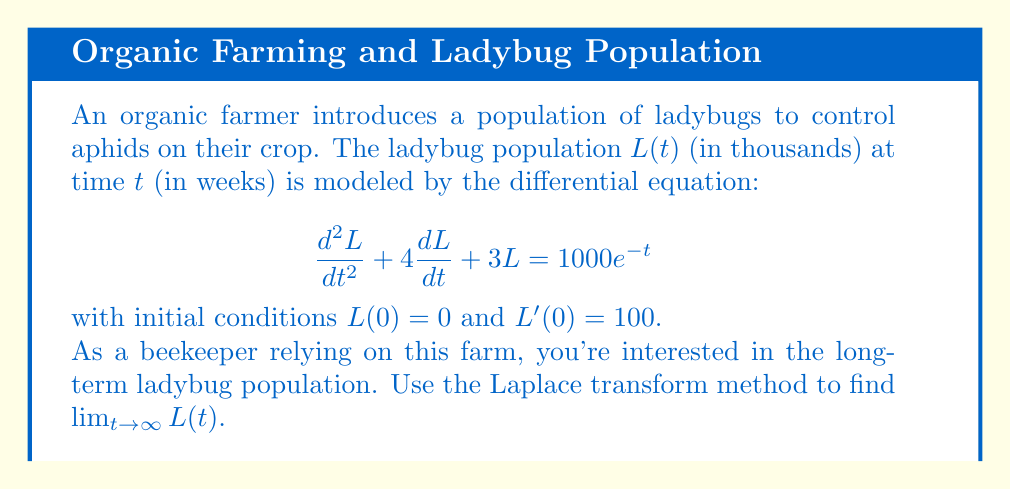What is the answer to this math problem? Let's solve this step-by-step using the Laplace transform method:

1) First, we take the Laplace transform of both sides of the equation:
   $$\mathcal{L}\{L''(t) + 4L'(t) + 3L(t)\} = \mathcal{L}\{1000e^{-t}\}$$

2) Using Laplace transform properties:
   $$(s^2\mathcal{L}\{L(t)\} - sL(0) - L'(0)) + 4(s\mathcal{L}\{L(t)\} - L(0)) + 3\mathcal{L}\{L(t)\} = \frac{1000}{s+1}$$

3) Let $\mathcal{L}\{L(t)\} = X(s)$. Substituting the initial conditions:
   $$(s^2X(s) - 0 - 100) + 4(sX(s) - 0) + 3X(s) = \frac{1000}{s+1}$$

4) Simplify:
   $$s^2X(s) + 4sX(s) + 3X(s) - 100 = \frac{1000}{s+1}$$
   $$(s^2 + 4s + 3)X(s) = \frac{1000}{s+1} + 100$$

5) Solve for $X(s)$:
   $$X(s) = \frac{1000}{(s+1)(s^2 + 4s + 3)} + \frac{100}{s^2 + 4s + 3}$$

6) Using partial fraction decomposition (details omitted for brevity):
   $$X(s) = \frac{250}{s+1} + \frac{-125}{s+1} + \frac{-125}{s+3} + \frac{100}{s+1} + \frac{-50}{s+3}$$

7) Simplify:
   $$X(s) = \frac{225}{s+1} + \frac{-175}{s+3}$$

8) Take the inverse Laplace transform:
   $$L(t) = 225e^{-t} - 175e^{-3t}$$

9) To find the limit as $t$ approaches infinity:
   $$\lim_{t \to \infty} L(t) = \lim_{t \to \infty} (225e^{-t} - 175e^{-3t}) = 0$$
Answer: $0$ 